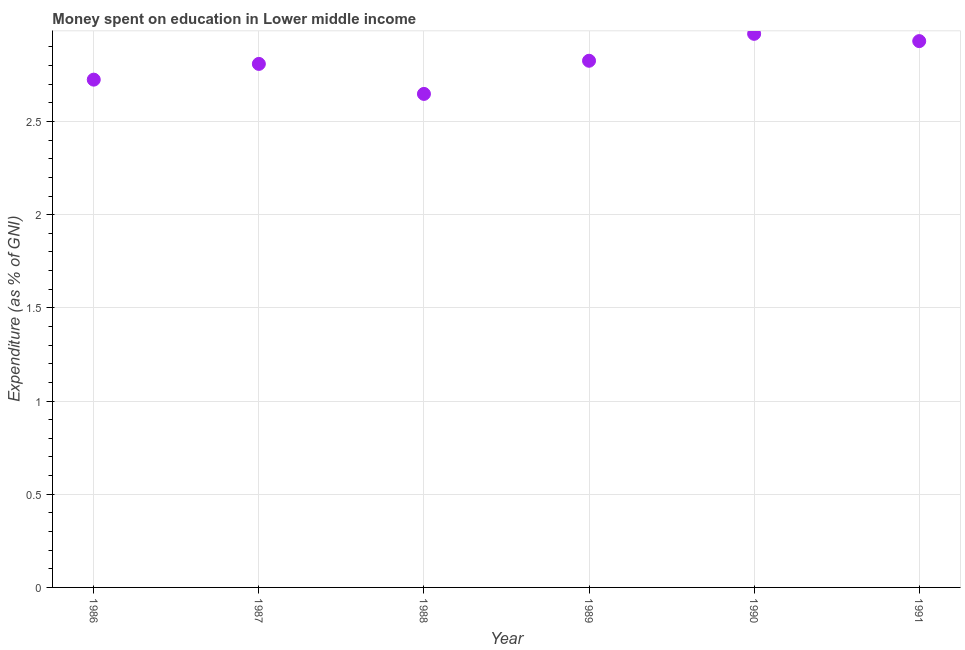What is the expenditure on education in 1989?
Give a very brief answer. 2.83. Across all years, what is the maximum expenditure on education?
Give a very brief answer. 2.97. Across all years, what is the minimum expenditure on education?
Your response must be concise. 2.65. In which year was the expenditure on education maximum?
Your response must be concise. 1990. What is the sum of the expenditure on education?
Provide a succinct answer. 16.91. What is the difference between the expenditure on education in 1987 and 1988?
Keep it short and to the point. 0.16. What is the average expenditure on education per year?
Your answer should be compact. 2.82. What is the median expenditure on education?
Make the answer very short. 2.82. In how many years, is the expenditure on education greater than 1.7 %?
Make the answer very short. 6. What is the ratio of the expenditure on education in 1988 to that in 1990?
Offer a very short reply. 0.89. Is the difference between the expenditure on education in 1989 and 1991 greater than the difference between any two years?
Give a very brief answer. No. What is the difference between the highest and the second highest expenditure on education?
Offer a very short reply. 0.04. What is the difference between the highest and the lowest expenditure on education?
Offer a very short reply. 0.32. In how many years, is the expenditure on education greater than the average expenditure on education taken over all years?
Offer a terse response. 3. Does the expenditure on education monotonically increase over the years?
Your answer should be very brief. No. What is the difference between two consecutive major ticks on the Y-axis?
Ensure brevity in your answer.  0.5. Are the values on the major ticks of Y-axis written in scientific E-notation?
Offer a very short reply. No. Does the graph contain any zero values?
Your answer should be very brief. No. What is the title of the graph?
Provide a short and direct response. Money spent on education in Lower middle income. What is the label or title of the Y-axis?
Give a very brief answer. Expenditure (as % of GNI). What is the Expenditure (as % of GNI) in 1986?
Give a very brief answer. 2.72. What is the Expenditure (as % of GNI) in 1987?
Offer a very short reply. 2.81. What is the Expenditure (as % of GNI) in 1988?
Your answer should be compact. 2.65. What is the Expenditure (as % of GNI) in 1989?
Provide a succinct answer. 2.83. What is the Expenditure (as % of GNI) in 1990?
Provide a short and direct response. 2.97. What is the Expenditure (as % of GNI) in 1991?
Give a very brief answer. 2.93. What is the difference between the Expenditure (as % of GNI) in 1986 and 1987?
Ensure brevity in your answer.  -0.08. What is the difference between the Expenditure (as % of GNI) in 1986 and 1988?
Your response must be concise. 0.08. What is the difference between the Expenditure (as % of GNI) in 1986 and 1989?
Your answer should be compact. -0.1. What is the difference between the Expenditure (as % of GNI) in 1986 and 1990?
Your answer should be compact. -0.25. What is the difference between the Expenditure (as % of GNI) in 1986 and 1991?
Make the answer very short. -0.21. What is the difference between the Expenditure (as % of GNI) in 1987 and 1988?
Offer a very short reply. 0.16. What is the difference between the Expenditure (as % of GNI) in 1987 and 1989?
Keep it short and to the point. -0.02. What is the difference between the Expenditure (as % of GNI) in 1987 and 1990?
Make the answer very short. -0.16. What is the difference between the Expenditure (as % of GNI) in 1987 and 1991?
Make the answer very short. -0.12. What is the difference between the Expenditure (as % of GNI) in 1988 and 1989?
Your response must be concise. -0.18. What is the difference between the Expenditure (as % of GNI) in 1988 and 1990?
Offer a very short reply. -0.32. What is the difference between the Expenditure (as % of GNI) in 1988 and 1991?
Provide a short and direct response. -0.28. What is the difference between the Expenditure (as % of GNI) in 1989 and 1990?
Provide a succinct answer. -0.14. What is the difference between the Expenditure (as % of GNI) in 1989 and 1991?
Your answer should be compact. -0.11. What is the difference between the Expenditure (as % of GNI) in 1990 and 1991?
Give a very brief answer. 0.04. What is the ratio of the Expenditure (as % of GNI) in 1986 to that in 1988?
Keep it short and to the point. 1.03. What is the ratio of the Expenditure (as % of GNI) in 1986 to that in 1990?
Give a very brief answer. 0.92. What is the ratio of the Expenditure (as % of GNI) in 1986 to that in 1991?
Offer a terse response. 0.93. What is the ratio of the Expenditure (as % of GNI) in 1987 to that in 1988?
Provide a succinct answer. 1.06. What is the ratio of the Expenditure (as % of GNI) in 1987 to that in 1990?
Your response must be concise. 0.95. What is the ratio of the Expenditure (as % of GNI) in 1987 to that in 1991?
Provide a succinct answer. 0.96. What is the ratio of the Expenditure (as % of GNI) in 1988 to that in 1989?
Your answer should be compact. 0.94. What is the ratio of the Expenditure (as % of GNI) in 1988 to that in 1990?
Provide a short and direct response. 0.89. What is the ratio of the Expenditure (as % of GNI) in 1988 to that in 1991?
Provide a succinct answer. 0.9. What is the ratio of the Expenditure (as % of GNI) in 1989 to that in 1990?
Your answer should be very brief. 0.95. What is the ratio of the Expenditure (as % of GNI) in 1990 to that in 1991?
Provide a short and direct response. 1.01. 